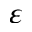<formula> <loc_0><loc_0><loc_500><loc_500>\varepsilon</formula> 